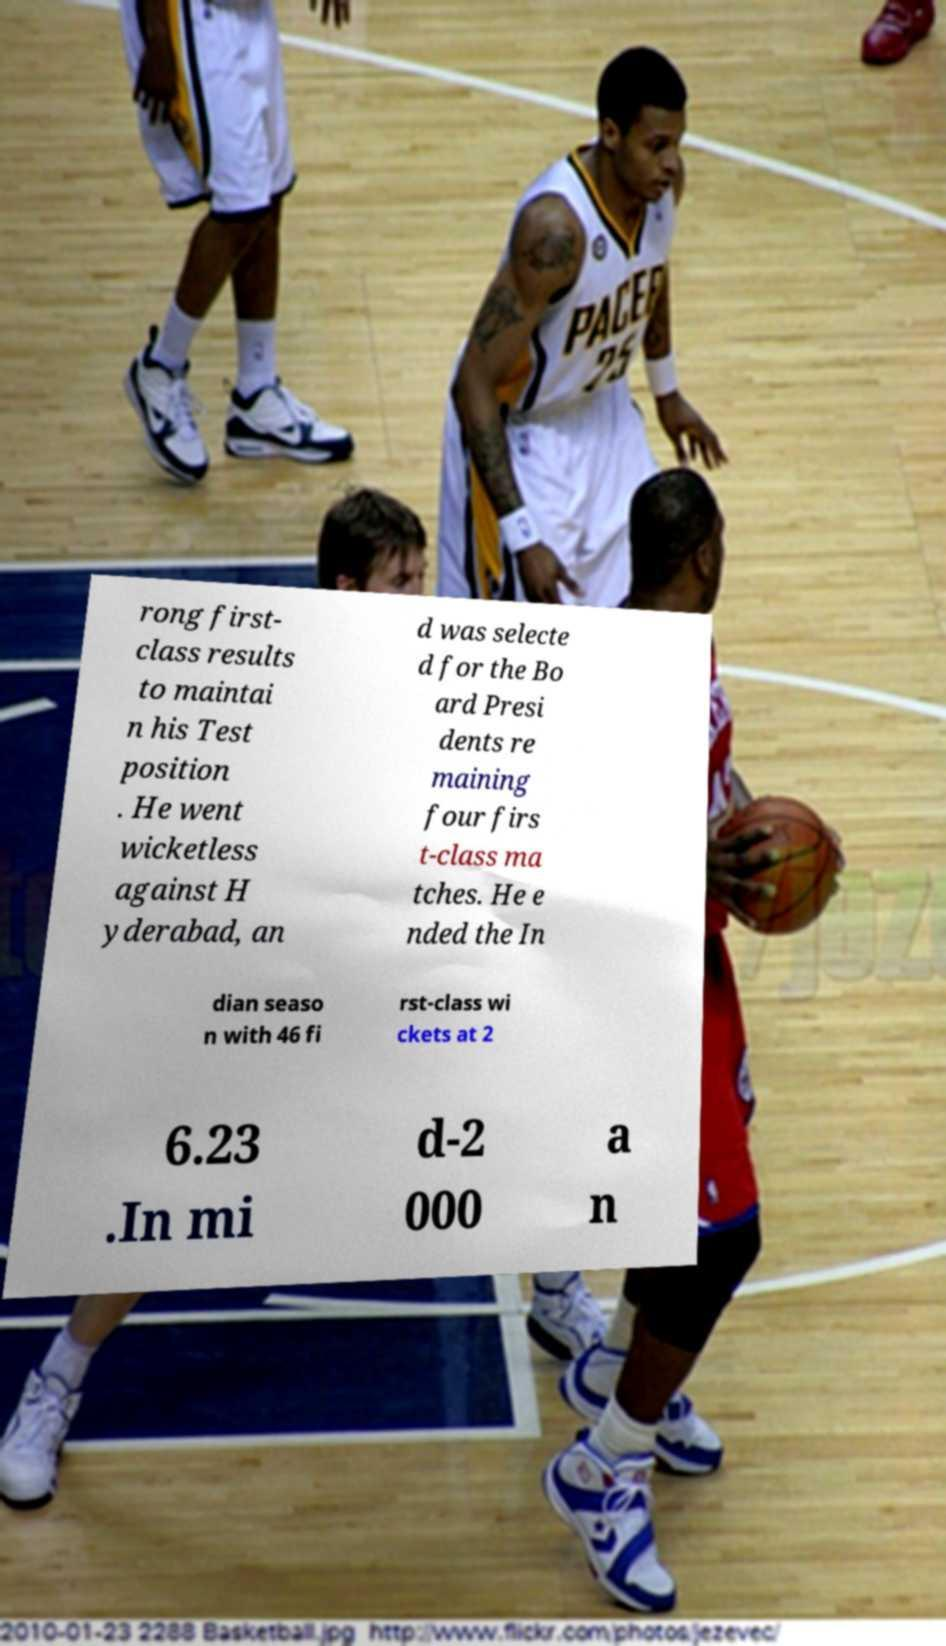Please read and relay the text visible in this image. What does it say? rong first- class results to maintai n his Test position . He went wicketless against H yderabad, an d was selecte d for the Bo ard Presi dents re maining four firs t-class ma tches. He e nded the In dian seaso n with 46 fi rst-class wi ckets at 2 6.23 .In mi d-2 000 a n 